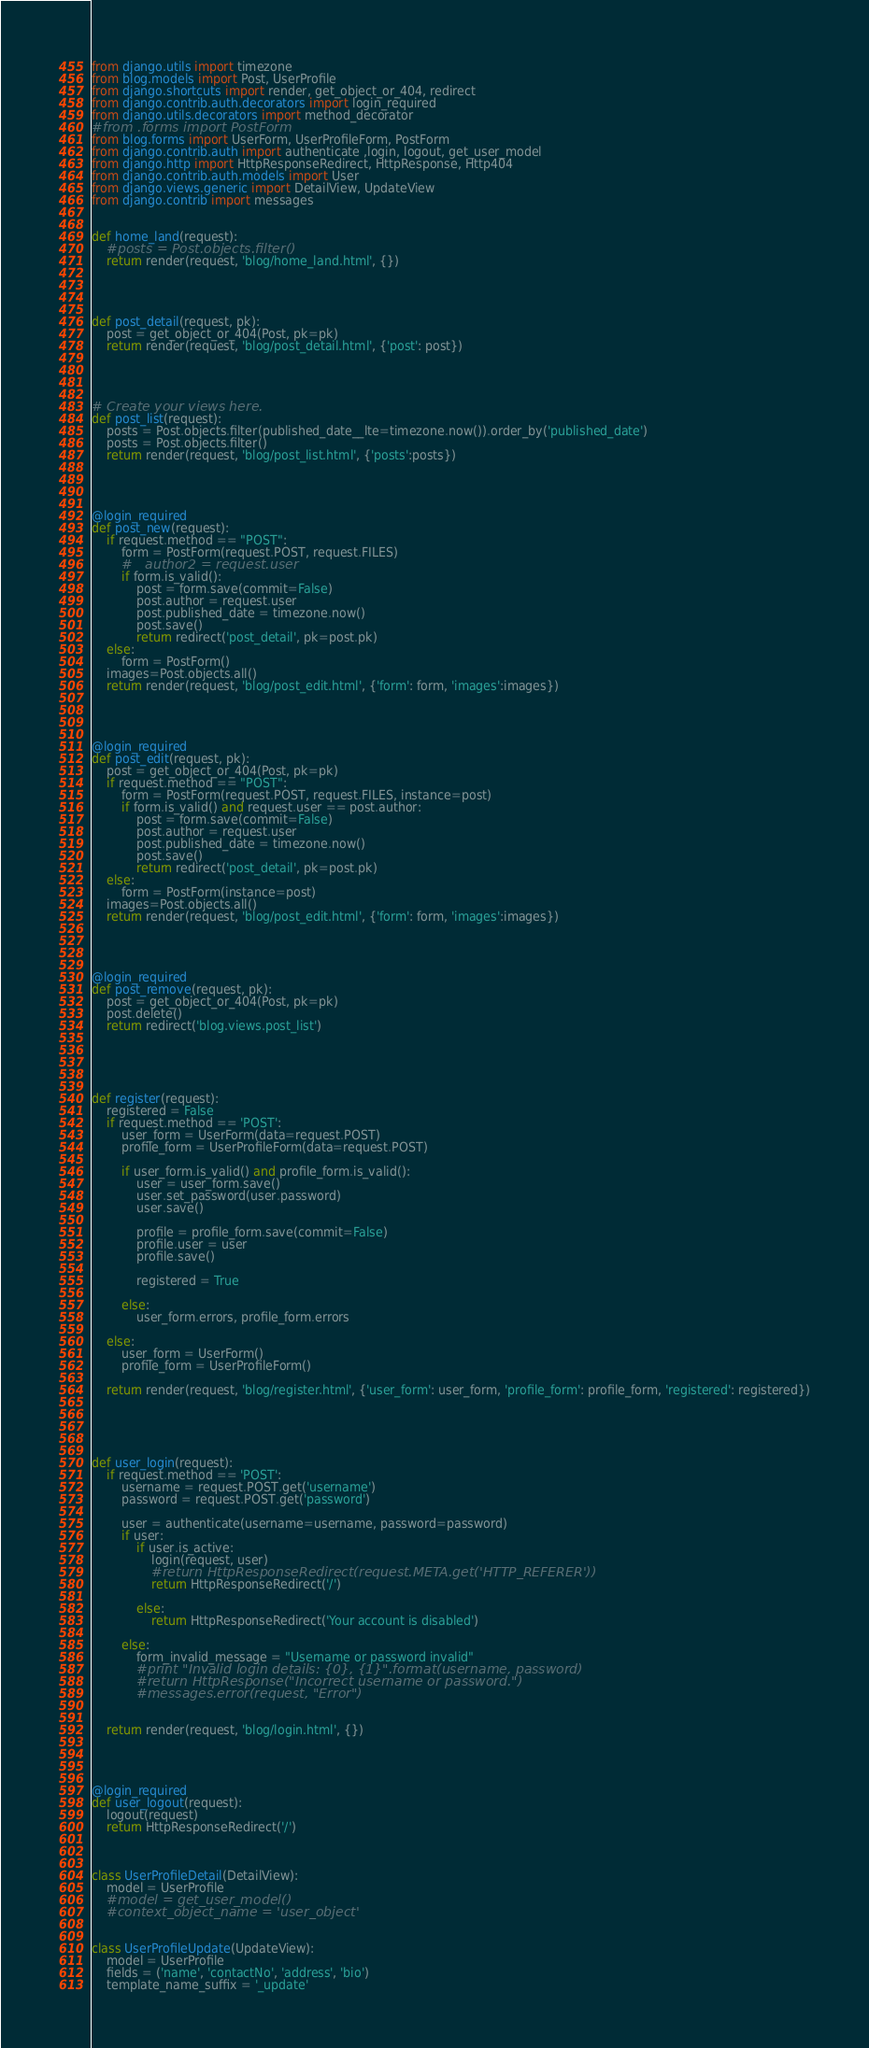Convert code to text. <code><loc_0><loc_0><loc_500><loc_500><_Python_>from django.utils import timezone
from blog.models import Post, UserProfile
from django.shortcuts import render, get_object_or_404, redirect
from django.contrib.auth.decorators import login_required
from django.utils.decorators import method_decorator
#from .forms import PostForm
from blog.forms import UserForm, UserProfileForm, PostForm
from django.contrib.auth import authenticate ,login, logout, get_user_model
from django.http import HttpResponseRedirect, HttpResponse, Http404
from django.contrib.auth.models import User
from django.views.generic import DetailView, UpdateView 
from django.contrib import messages 


def home_land(request):
    #posts = Post.objects.filter()
    return render(request, 'blog/home_land.html', {})




def post_detail(request, pk):
    post = get_object_or_404(Post, pk=pk)
    return render(request, 'blog/post_detail.html', {'post': post})




# Create your views here.
def post_list(request):
    posts = Post.objects.filter(published_date__lte=timezone.now()).order_by('published_date')
    posts = Post.objects.filter()
    return render(request, 'blog/post_list.html', {'posts':posts})




@login_required
def post_new(request):
    if request.method == "POST":
        form = PostForm(request.POST, request.FILES)
        #   author2 = request.user
        if form.is_valid():
            post = form.save(commit=False)
            post.author = request.user
            post.published_date = timezone.now()
            post.save()
            return redirect('post_detail', pk=post.pk)
    else:
        form = PostForm()
    images=Post.objects.all()
    return render(request, 'blog/post_edit.html', {'form': form, 'images':images})




@login_required
def post_edit(request, pk):
    post = get_object_or_404(Post, pk=pk)
    if request.method == "POST":
        form = PostForm(request.POST, request.FILES, instance=post)
        if form.is_valid() and request.user == post.author:
            post = form.save(commit=False)
            post.author = request.user
            post.published_date = timezone.now()
            post.save()
            return redirect('post_detail', pk=post.pk)
    else:
        form = PostForm(instance=post)
    images=Post.objects.all()
    return render(request, 'blog/post_edit.html', {'form': form, 'images':images})




@login_required
def post_remove(request, pk):
    post = get_object_or_404(Post, pk=pk)
    post.delete()
    return redirect('blog.views.post_list')





def register(request):
    registered = False
    if request.method == 'POST':
        user_form = UserForm(data=request.POST)
        profile_form = UserProfileForm(data=request.POST)

        if user_form.is_valid() and profile_form.is_valid():
            user = user_form.save()
            user.set_password(user.password)
            user.save()

            profile = profile_form.save(commit=False)
            profile.user = user
            profile.save()

            registered = True

        else:
            user_form.errors, profile_form.errors

    else:
        user_form = UserForm()
        profile_form = UserProfileForm()

    return render(request, 'blog/register.html', {'user_form': user_form, 'profile_form': profile_form, 'registered': registered})





def user_login(request):
    if request.method == 'POST':
        username = request.POST.get('username')
        password = request.POST.get('password')

        user = authenticate(username=username, password=password)
        if user:
            if user.is_active:
                login(request, user)
                #return HttpResponseRedirect(request.META.get('HTTP_REFERER'))
                return HttpResponseRedirect('/')

            else:
                return HttpResponseRedirect('Your account is disabled')

        else:
            form_invalid_message = "Username or password invalid"
            #print "Invalid login details: {0}, {1}".format(username, password)
            #return HttpResponse("Incorrect username or password.")
            #messages.error(request, "Error")


    return render(request, 'blog/login.html', {})




@login_required
def user_logout(request):
    logout(request)
    return HttpResponseRedirect('/')



class UserProfileDetail(DetailView):
    model = UserProfile
    #model = get_user_model()
    #context_object_name = 'user_object'


class UserProfileUpdate(UpdateView):
    model = UserProfile
    fields = ('name', 'contactNo', 'address', 'bio')
    template_name_suffix = '_update'
</code> 